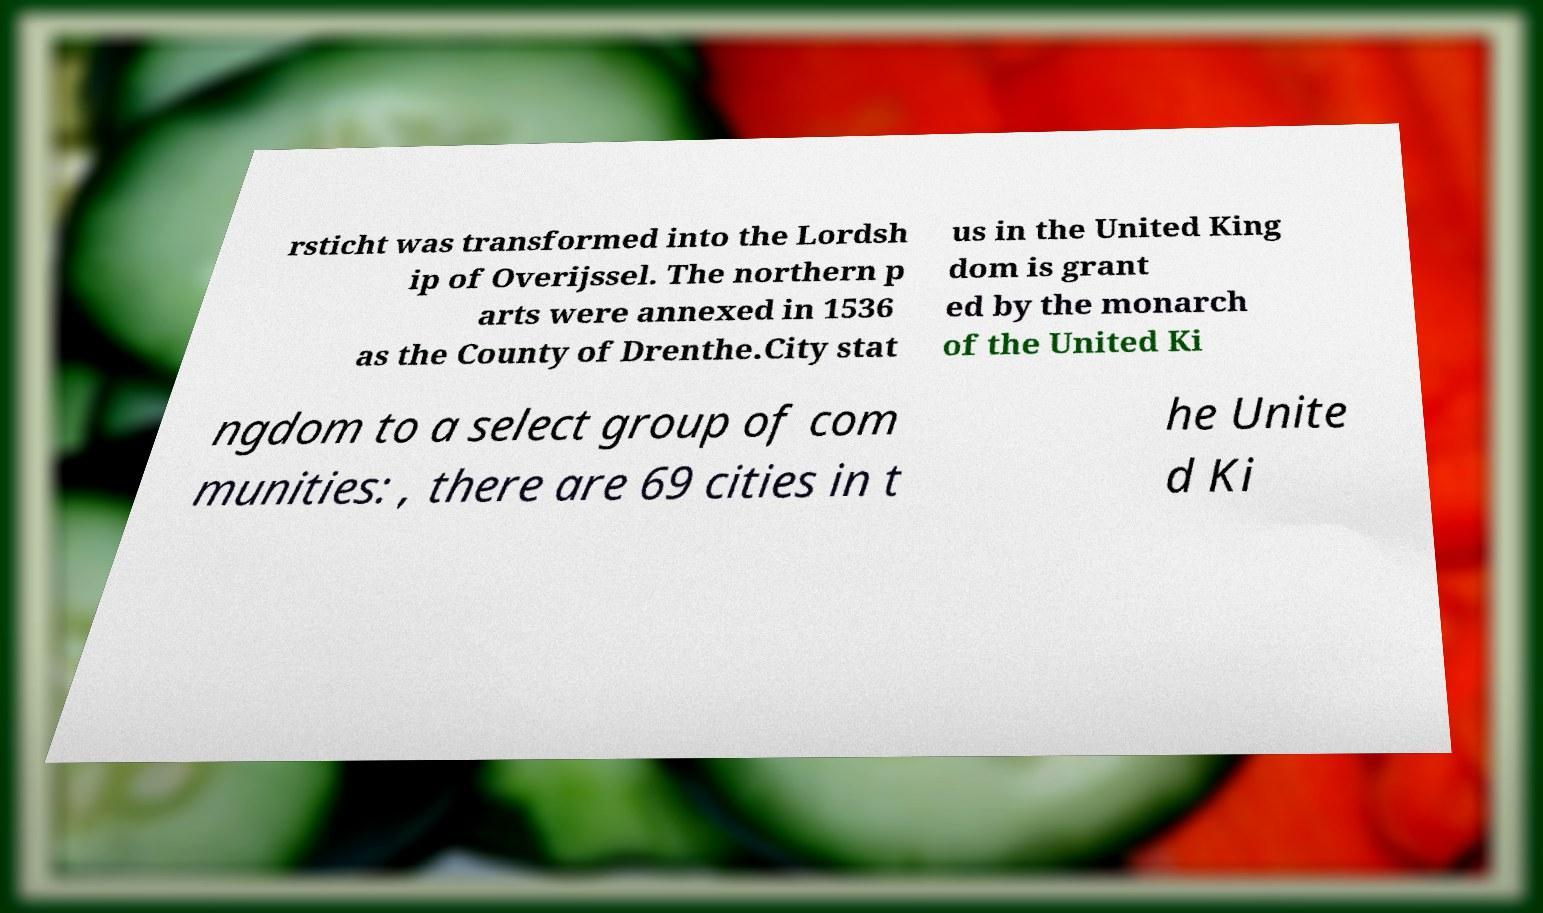Please read and relay the text visible in this image. What does it say? rsticht was transformed into the Lordsh ip of Overijssel. The northern p arts were annexed in 1536 as the County of Drenthe.City stat us in the United King dom is grant ed by the monarch of the United Ki ngdom to a select group of com munities: , there are 69 cities in t he Unite d Ki 